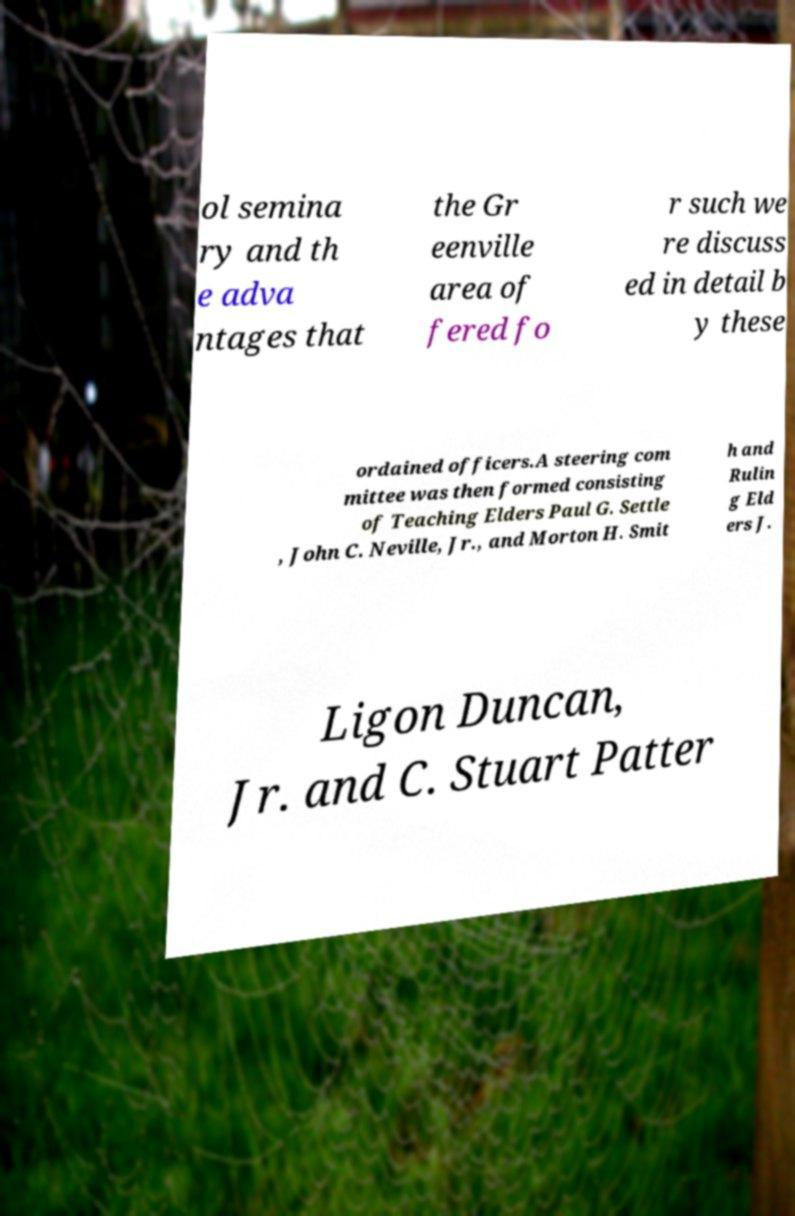Please identify and transcribe the text found in this image. ol semina ry and th e adva ntages that the Gr eenville area of fered fo r such we re discuss ed in detail b y these ordained officers.A steering com mittee was then formed consisting of Teaching Elders Paul G. Settle , John C. Neville, Jr., and Morton H. Smit h and Rulin g Eld ers J. Ligon Duncan, Jr. and C. Stuart Patter 